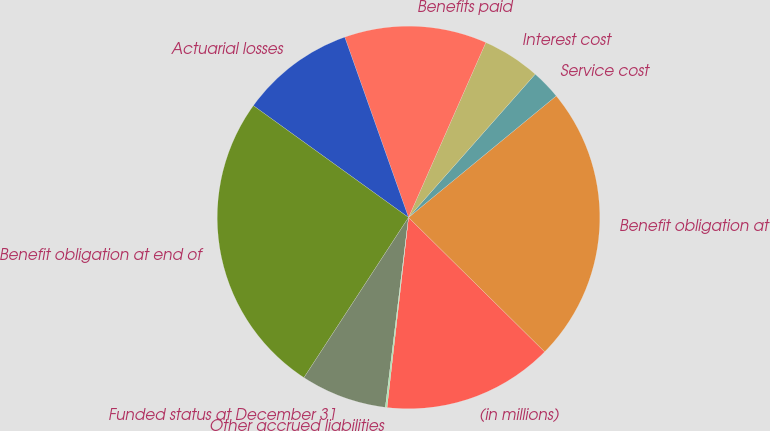Convert chart to OTSL. <chart><loc_0><loc_0><loc_500><loc_500><pie_chart><fcel>(in millions)<fcel>Benefit obligation at<fcel>Service cost<fcel>Interest cost<fcel>Benefits paid<fcel>Actuarial losses<fcel>Benefit obligation at end of<fcel>Funded status at December 31<fcel>Other accrued liabilities<nl><fcel>14.4%<fcel>23.35%<fcel>2.52%<fcel>4.9%<fcel>12.03%<fcel>9.65%<fcel>25.73%<fcel>7.27%<fcel>0.14%<nl></chart> 